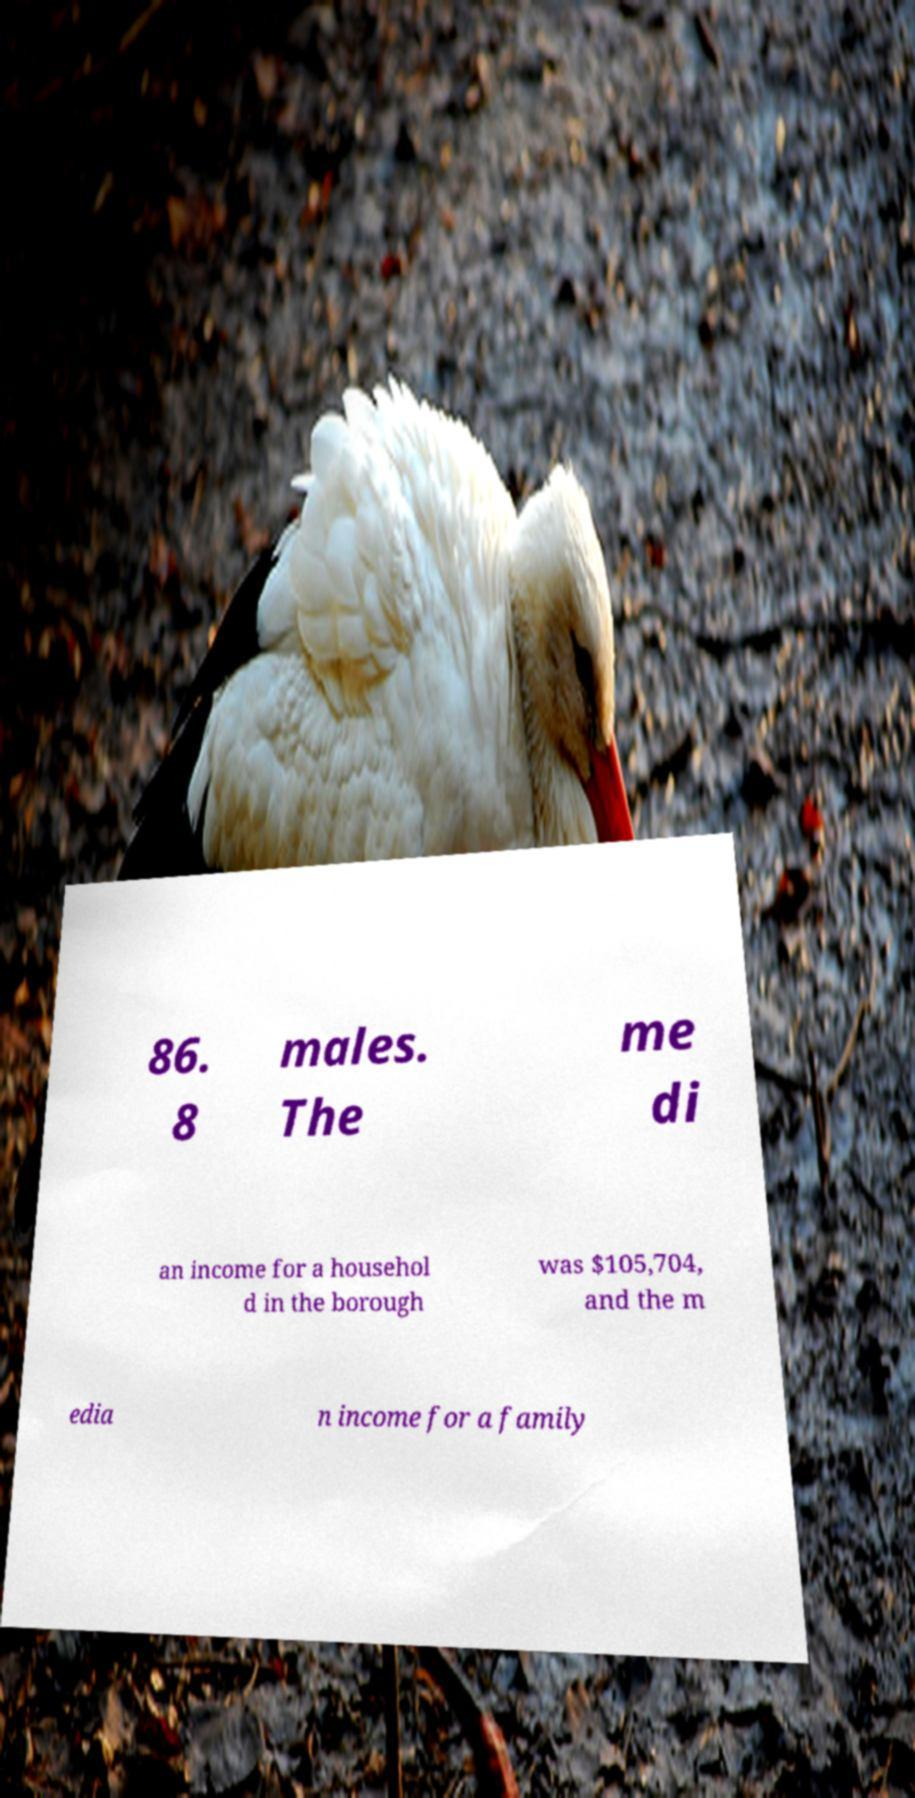Please identify and transcribe the text found in this image. 86. 8 males. The me di an income for a househol d in the borough was $105,704, and the m edia n income for a family 